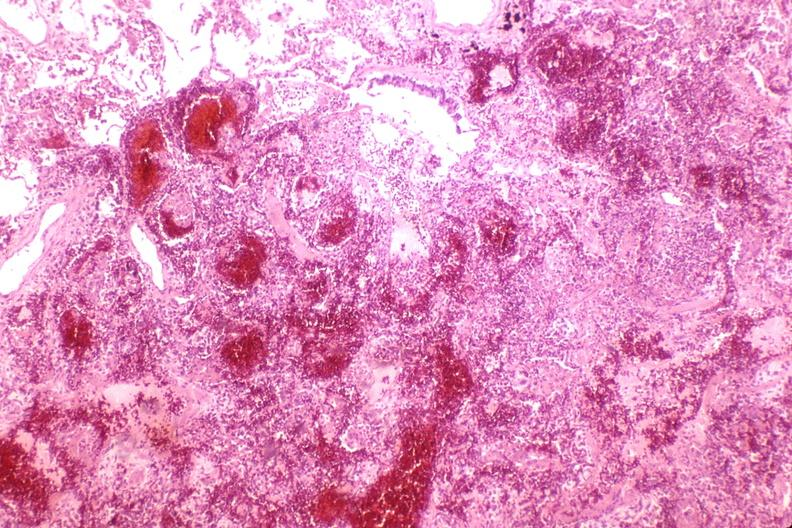does this image show lung, hemorrhagic bronchopneumonia, wilson 's disease?
Answer the question using a single word or phrase. Yes 